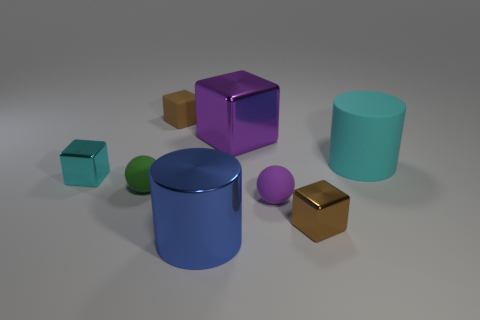Subtract all cyan spheres. How many brown blocks are left? 2 Subtract all purple blocks. How many blocks are left? 3 Subtract all large purple cubes. How many cubes are left? 3 Add 1 small green shiny cubes. How many objects exist? 9 Subtract all balls. How many objects are left? 6 Subtract all yellow cubes. Subtract all cyan balls. How many cubes are left? 4 Add 8 small matte blocks. How many small matte blocks are left? 9 Add 1 tiny matte balls. How many tiny matte balls exist? 3 Subtract 1 purple blocks. How many objects are left? 7 Subtract all shiny cubes. Subtract all large rubber objects. How many objects are left? 4 